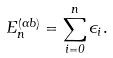Convert formula to latex. <formula><loc_0><loc_0><loc_500><loc_500>E _ { n } ^ { ( \alpha b ) } = \sum _ { i = 0 } ^ { n } \epsilon _ { i } .</formula> 